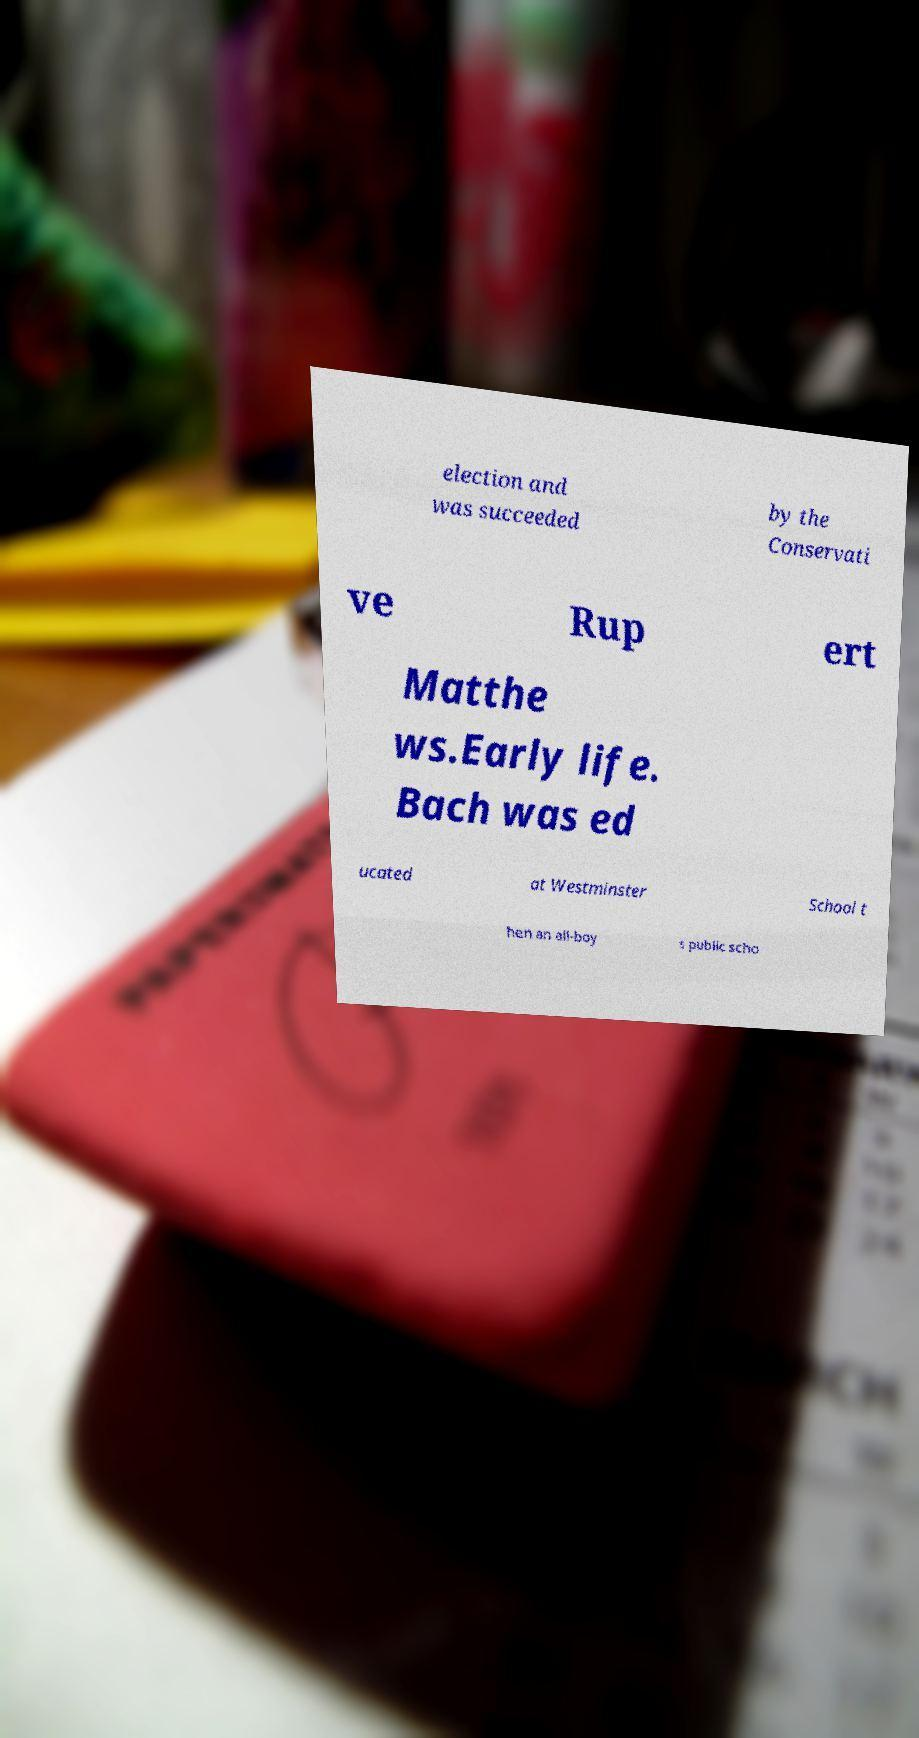Could you assist in decoding the text presented in this image and type it out clearly? election and was succeeded by the Conservati ve Rup ert Matthe ws.Early life. Bach was ed ucated at Westminster School t hen an all-boy s public scho 